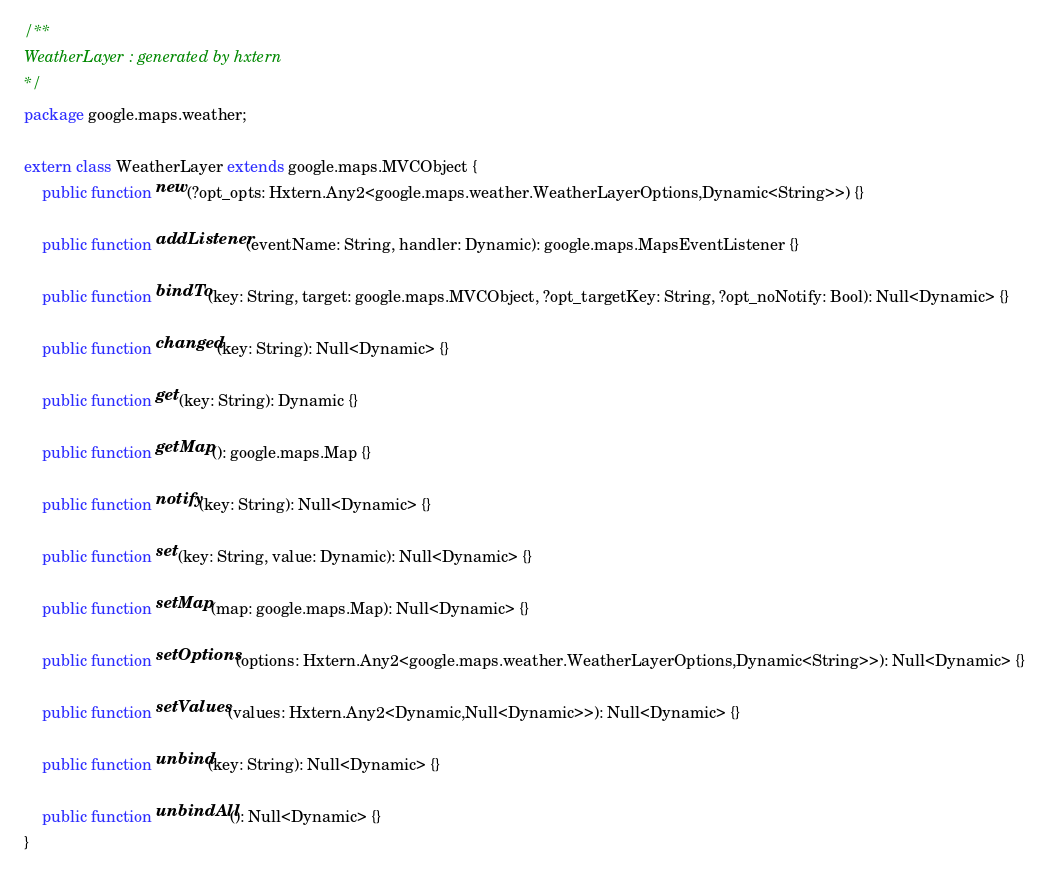<code> <loc_0><loc_0><loc_500><loc_500><_Haxe_>/**
WeatherLayer : generated by hxtern
*/
package google.maps.weather;

extern class WeatherLayer extends google.maps.MVCObject {
	public function new(?opt_opts: Hxtern.Any2<google.maps.weather.WeatherLayerOptions,Dynamic<String>>) {}

	public function addListener(eventName: String, handler: Dynamic): google.maps.MapsEventListener {}

	public function bindTo(key: String, target: google.maps.MVCObject, ?opt_targetKey: String, ?opt_noNotify: Bool): Null<Dynamic> {}

	public function changed(key: String): Null<Dynamic> {}

	public function get(key: String): Dynamic {}

	public function getMap(): google.maps.Map {}

	public function notify(key: String): Null<Dynamic> {}

	public function set(key: String, value: Dynamic): Null<Dynamic> {}

	public function setMap(map: google.maps.Map): Null<Dynamic> {}

	public function setOptions(options: Hxtern.Any2<google.maps.weather.WeatherLayerOptions,Dynamic<String>>): Null<Dynamic> {}

	public function setValues(values: Hxtern.Any2<Dynamic,Null<Dynamic>>): Null<Dynamic> {}

	public function unbind(key: String): Null<Dynamic> {}

	public function unbindAll(): Null<Dynamic> {}
}
</code> 